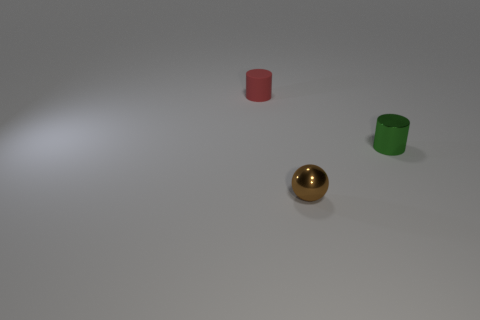Add 1 small gray matte things. How many objects exist? 4 Subtract all balls. How many objects are left? 2 Add 1 large brown balls. How many large brown balls exist? 1 Subtract 1 brown balls. How many objects are left? 2 Subtract all red matte cylinders. Subtract all green things. How many objects are left? 1 Add 2 green things. How many green things are left? 3 